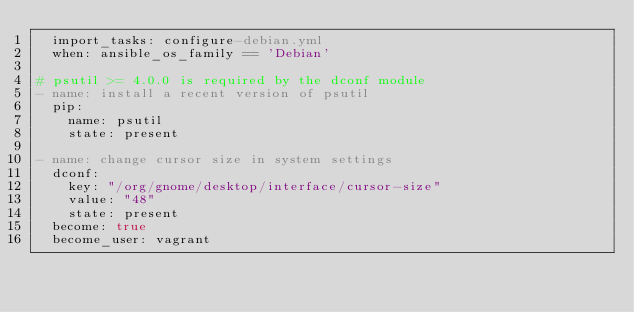Convert code to text. <code><loc_0><loc_0><loc_500><loc_500><_YAML_>  import_tasks: configure-debian.yml
  when: ansible_os_family == 'Debian'

# psutil >= 4.0.0 is required by the dconf module
- name: install a recent version of psutil
  pip:
    name: psutil
    state: present

- name: change cursor size in system settings
  dconf:
    key: "/org/gnome/desktop/interface/cursor-size"
    value: "48"
    state: present
  become: true
  become_user: vagrant
</code> 